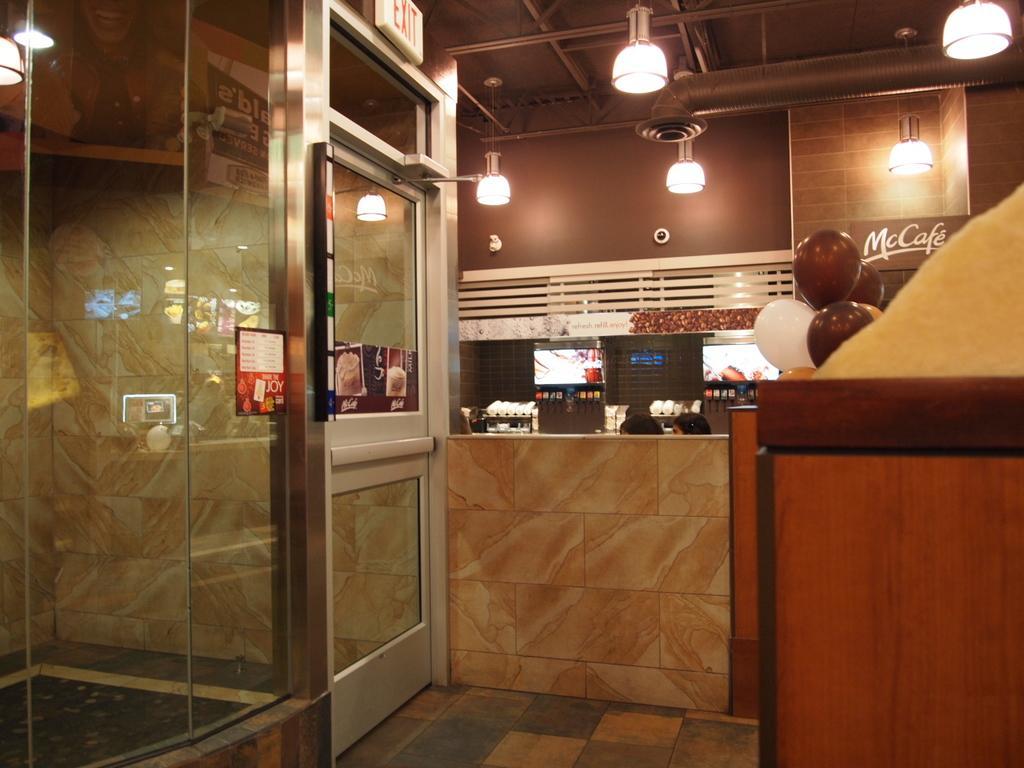Could you give a brief overview of what you see in this image? On the left side of the image there are glass walls and a glass door with posters on it. Beside them there is a wall. Behind the wall there are two heads of humans. Behind them there are machines. And also there is a board with a name on it. On the right side the image there is a table. Behind the table there are balloons. At the top of the image there is a ceiling with lights and a chimney. 